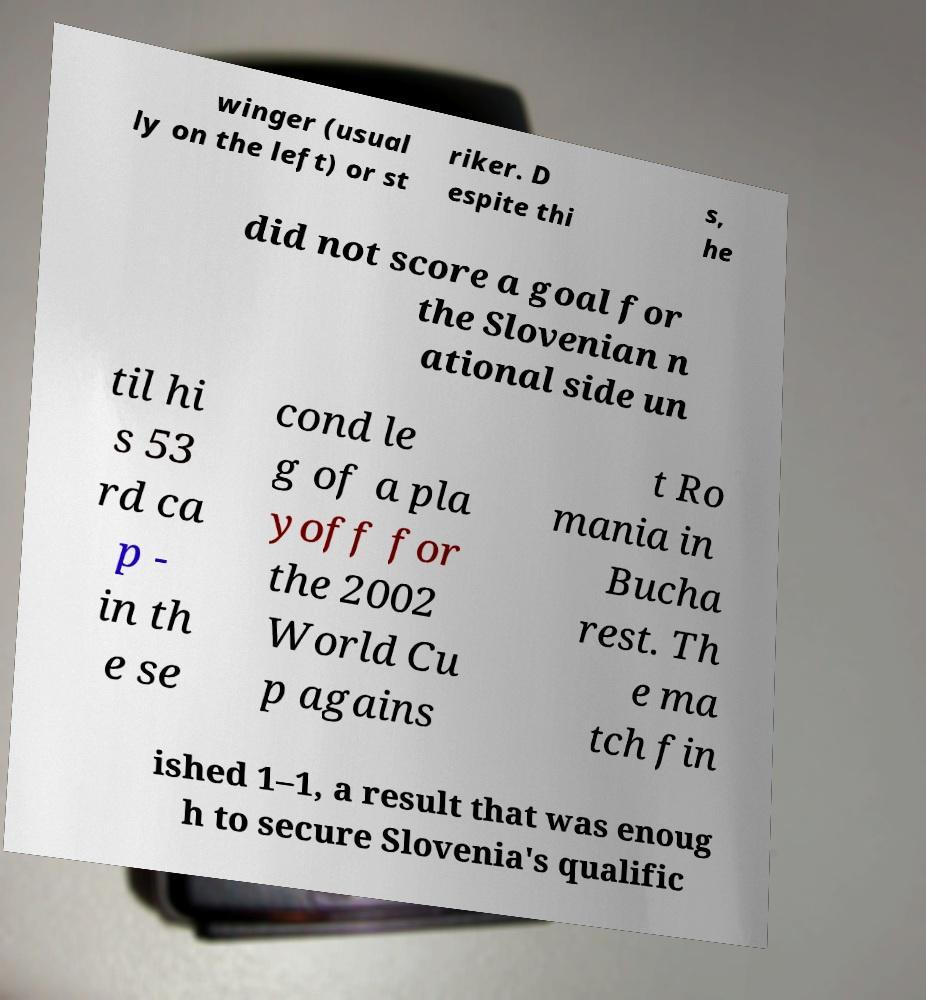Could you assist in decoding the text presented in this image and type it out clearly? winger (usual ly on the left) or st riker. D espite thi s, he did not score a goal for the Slovenian n ational side un til hi s 53 rd ca p - in th e se cond le g of a pla yoff for the 2002 World Cu p agains t Ro mania in Bucha rest. Th e ma tch fin ished 1–1, a result that was enoug h to secure Slovenia's qualific 